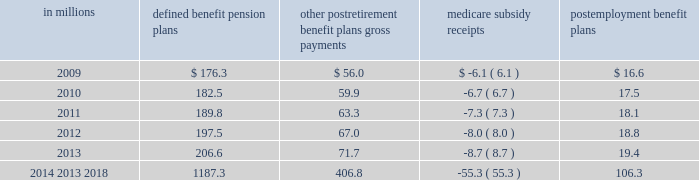Contributions and future benefit payments we expect to make contributions of $ 28.1 million to our defined benefit , other postretirement , and postemployment benefits plans in fiscal 2009 .
Actual 2009 contributions could exceed our current projections , as influenced by our decision to undertake discretionary funding of our benefit trusts versus other competing investment priorities and future changes in government requirements .
Estimated benefit payments , which reflect expected future service , as appropriate , are expected to be paid from fiscal 2009-2018 as follows : in millions defined benefit pension postretirement benefit plans gross payments medicare subsidy receipts postemployment benefit ......................................................................................................................................................................................... .
Defined contribution plans the general mills savings plan is a defined contribution plan that covers salaried and nonunion employees .
It had net assets of $ 2309.9 million as of may 25 , 2008 and $ 2303.0 million as of may 27 , 2007.this plan is a 401 ( k ) savings plan that includes a number of investment funds and an employee stock ownership plan ( esop ) .
We sponsor another savings plan for certain hourly employees with net assets of $ 16.0 million as of may 25 , 2008 .
Our total recognized expense related to defined contribution plans was $ 61.9 million in fiscal 2008 , $ 48.3 million in fiscal 2007 , and $ 45.5 million in fiscal 2006 .
The esop originally purchased our common stock principally with funds borrowed from third parties and guaranteed by us.the esop shares are included in net shares outstanding for the purposes of calculating eps .
The esop 2019s third-party debt was repaid on june 30 , 2007 .
The esop 2019s only assets are our common stock and temporary cash balances.the esop 2019s share of the total defined contribution expense was $ 52.3 million in fiscal 2008 , $ 40.1 million in fiscal 2007 , and $ 37.6 million in fiscal 2006 .
The esop 2019s expensewas calculated by the 201cshares allocated 201dmethod .
The esop used our common stock to convey benefits to employees and , through increased stock ownership , to further align employee interests with those of stockholders.wematched a percentage of employee contributions to the general mills savings plan with a base match plus a variable year end match that depended on annual results .
Employees received our match in the form of common stock .
Our cash contribution to the esop was calculated so as to pay off enough debt to release sufficient shares to make our match .
The esop used our cash contributions to the plan , plus the dividends received on the esop 2019s leveraged shares , to make principal and interest payments on the esop 2019s debt .
As loan payments were made , shares became unencumbered by debt and were committed to be allocated .
The esop allocated shares to individual employee accounts on the basis of the match of employee payroll savings ( contributions ) , plus reinvested dividends received on previously allocated shares .
The esop incurred net interest of less than $ 1.0 million in each of fiscal 2007 and 2006 .
The esop used dividends of $ 2.5 million in fiscal 2007 and $ 3.9 million in 2006 , along with our contributions of less than $ 1.0 million in each of fiscal 2007 and 2006 to make interest and principal payments .
The number of shares of our common stock allocated to participants in the esop was 5.2 million as of may 25 , 2008 , and 5.4 million as of may 27 , 2007 .
Annual report 2008 81 .
What is the total estimated benefit payment for 2009? 
Computations: (((176.3 + 56.0) - 6.1) + 16.6)
Answer: 242.8. 